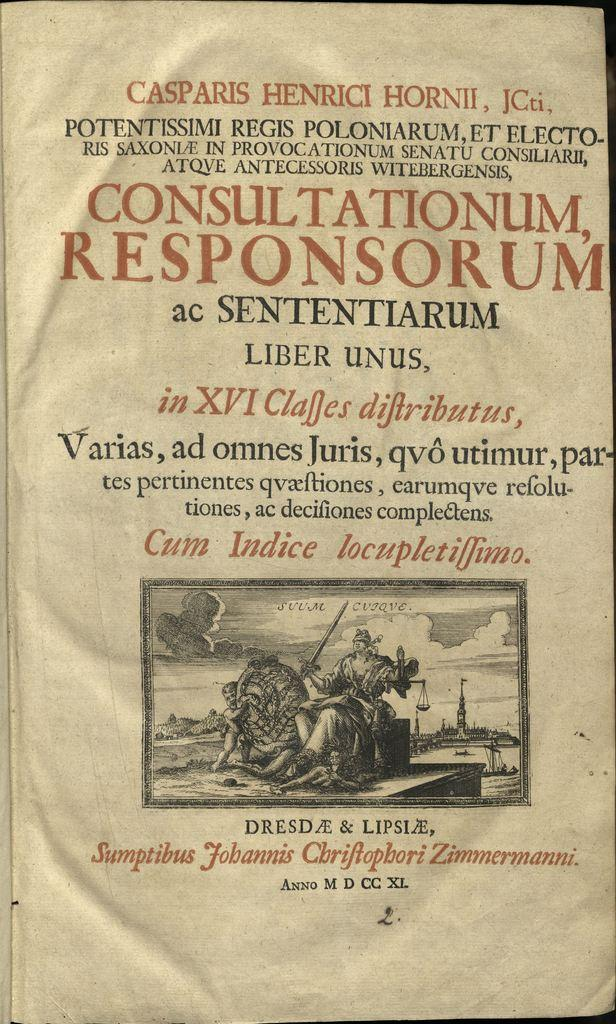<image>
Render a clear and concise summary of the photo. A book called Consultationum Responsorum is open to the title page. 